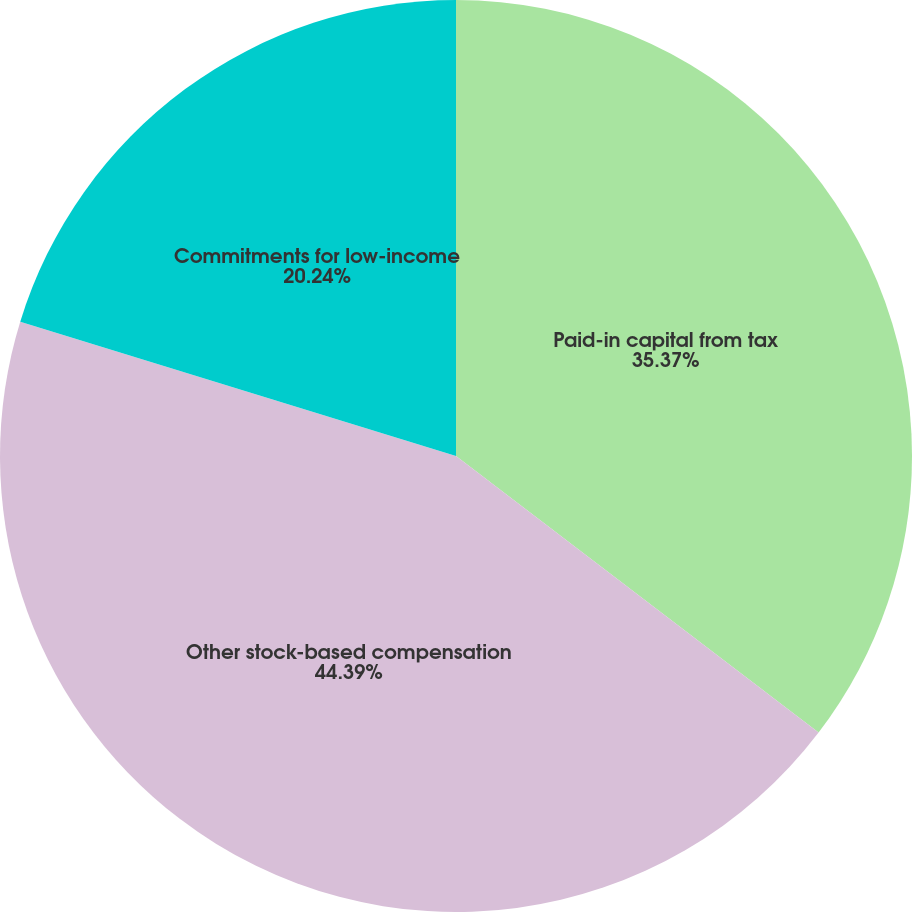Convert chart. <chart><loc_0><loc_0><loc_500><loc_500><pie_chart><fcel>Paid-in capital from tax<fcel>Other stock-based compensation<fcel>Commitments for low-income<nl><fcel>35.37%<fcel>44.39%<fcel>20.24%<nl></chart> 